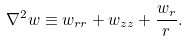<formula> <loc_0><loc_0><loc_500><loc_500>\nabla ^ { 2 } w \equiv w _ { r r } + w _ { z z } + \frac { w _ { r } } { r } .</formula> 